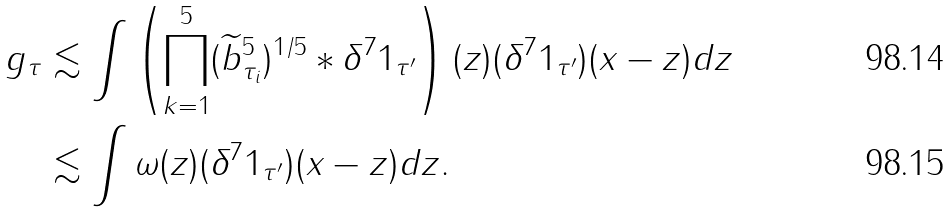<formula> <loc_0><loc_0><loc_500><loc_500>g _ { \tau } & \lesssim \int \left ( \prod _ { k = 1 } ^ { 5 } ( \widetilde { b } _ { \tau _ { i } } ^ { 5 } ) ^ { 1 / 5 } \ast \delta ^ { 7 } 1 _ { \tau ^ { \prime } } \right ) ( z ) ( \delta ^ { 7 } 1 _ { \tau ^ { \prime } } ) ( x - z ) d z \\ & \lesssim \int \omega ( z ) ( \delta ^ { 7 } 1 _ { \tau ^ { \prime } } ) ( x - z ) d z .</formula> 